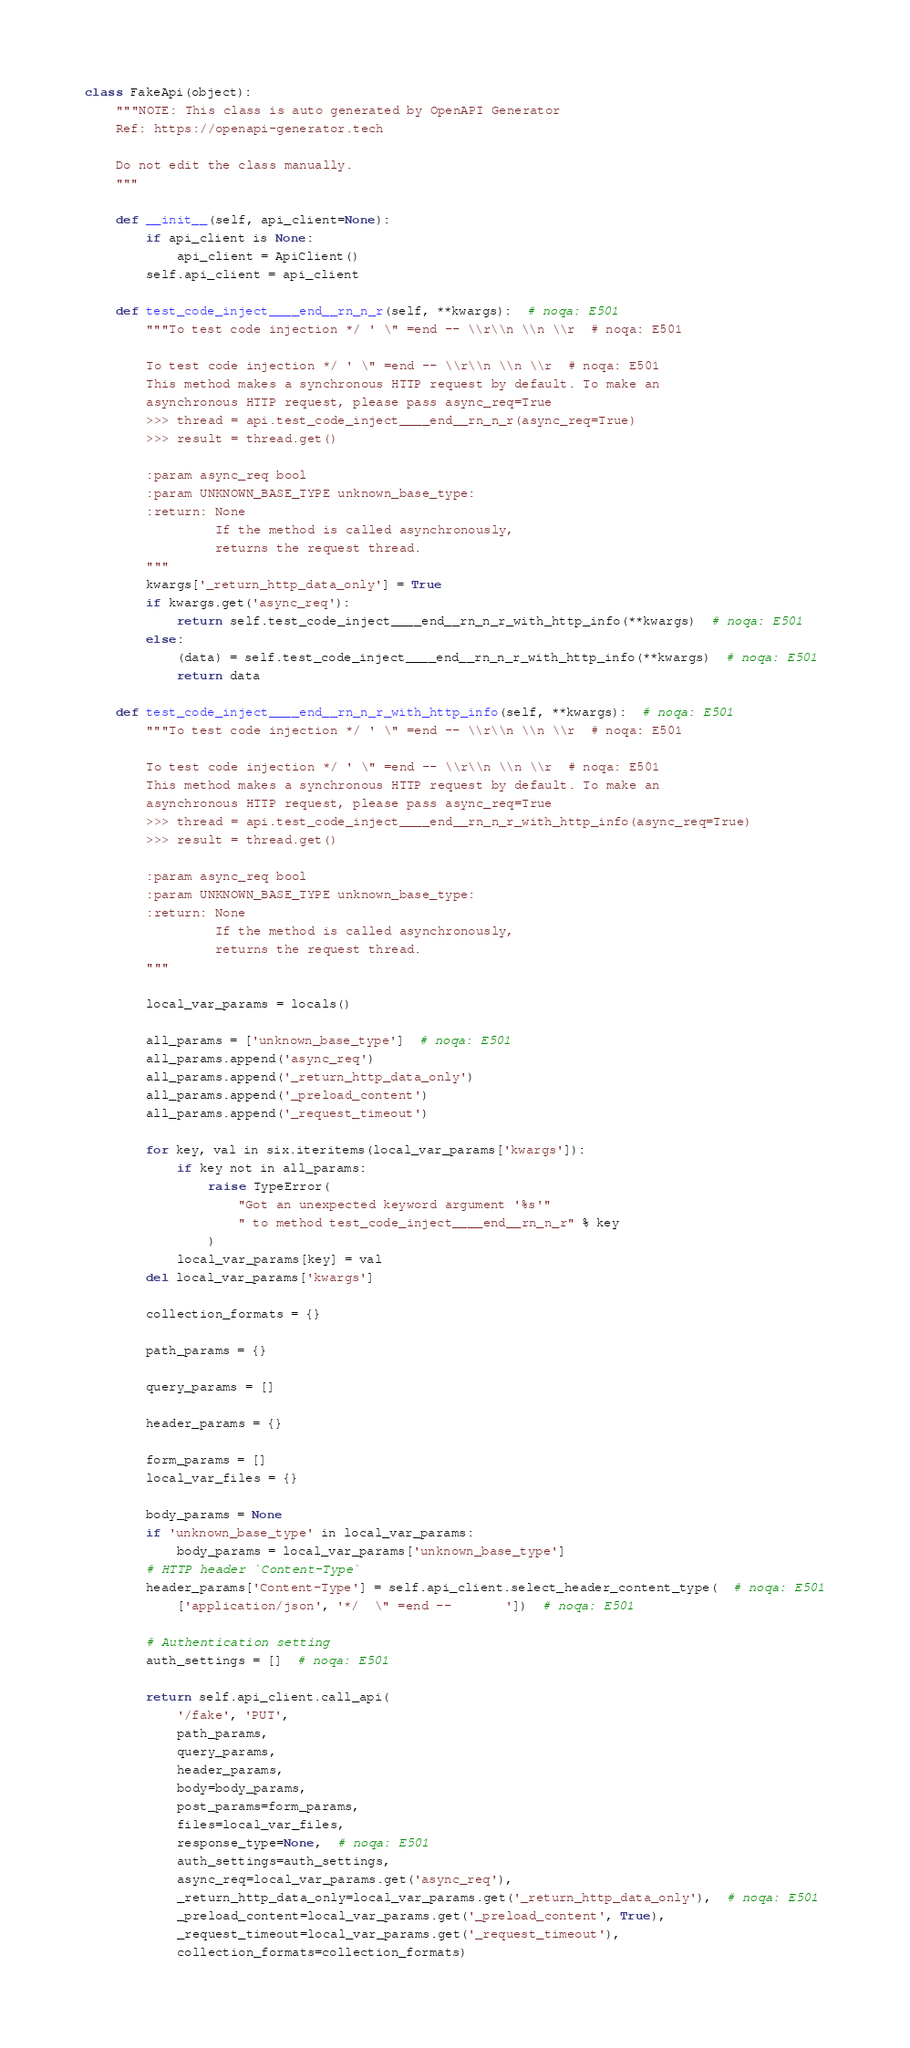Convert code to text. <code><loc_0><loc_0><loc_500><loc_500><_Python_>class FakeApi(object):
    """NOTE: This class is auto generated by OpenAPI Generator
    Ref: https://openapi-generator.tech

    Do not edit the class manually.
    """

    def __init__(self, api_client=None):
        if api_client is None:
            api_client = ApiClient()
        self.api_client = api_client

    def test_code_inject____end__rn_n_r(self, **kwargs):  # noqa: E501
        """To test code injection */ ' \" =end -- \\r\\n \\n \\r  # noqa: E501

        To test code injection */ ' \" =end -- \\r\\n \\n \\r  # noqa: E501
        This method makes a synchronous HTTP request by default. To make an
        asynchronous HTTP request, please pass async_req=True
        >>> thread = api.test_code_inject____end__rn_n_r(async_req=True)
        >>> result = thread.get()

        :param async_req bool
        :param UNKNOWN_BASE_TYPE unknown_base_type:
        :return: None
                 If the method is called asynchronously,
                 returns the request thread.
        """
        kwargs['_return_http_data_only'] = True
        if kwargs.get('async_req'):
            return self.test_code_inject____end__rn_n_r_with_http_info(**kwargs)  # noqa: E501
        else:
            (data) = self.test_code_inject____end__rn_n_r_with_http_info(**kwargs)  # noqa: E501
            return data

    def test_code_inject____end__rn_n_r_with_http_info(self, **kwargs):  # noqa: E501
        """To test code injection */ ' \" =end -- \\r\\n \\n \\r  # noqa: E501

        To test code injection */ ' \" =end -- \\r\\n \\n \\r  # noqa: E501
        This method makes a synchronous HTTP request by default. To make an
        asynchronous HTTP request, please pass async_req=True
        >>> thread = api.test_code_inject____end__rn_n_r_with_http_info(async_req=True)
        >>> result = thread.get()

        :param async_req bool
        :param UNKNOWN_BASE_TYPE unknown_base_type:
        :return: None
                 If the method is called asynchronously,
                 returns the request thread.
        """

        local_var_params = locals()

        all_params = ['unknown_base_type']  # noqa: E501
        all_params.append('async_req')
        all_params.append('_return_http_data_only')
        all_params.append('_preload_content')
        all_params.append('_request_timeout')

        for key, val in six.iteritems(local_var_params['kwargs']):
            if key not in all_params:
                raise TypeError(
                    "Got an unexpected keyword argument '%s'"
                    " to method test_code_inject____end__rn_n_r" % key
                )
            local_var_params[key] = val
        del local_var_params['kwargs']

        collection_formats = {}

        path_params = {}

        query_params = []

        header_params = {}

        form_params = []
        local_var_files = {}

        body_params = None
        if 'unknown_base_type' in local_var_params:
            body_params = local_var_params['unknown_base_type']
        # HTTP header `Content-Type`
        header_params['Content-Type'] = self.api_client.select_header_content_type(  # noqa: E501
            ['application/json', '*/  \" =end --       '])  # noqa: E501

        # Authentication setting
        auth_settings = []  # noqa: E501

        return self.api_client.call_api(
            '/fake', 'PUT',
            path_params,
            query_params,
            header_params,
            body=body_params,
            post_params=form_params,
            files=local_var_files,
            response_type=None,  # noqa: E501
            auth_settings=auth_settings,
            async_req=local_var_params.get('async_req'),
            _return_http_data_only=local_var_params.get('_return_http_data_only'),  # noqa: E501
            _preload_content=local_var_params.get('_preload_content', True),
            _request_timeout=local_var_params.get('_request_timeout'),
            collection_formats=collection_formats)
</code> 